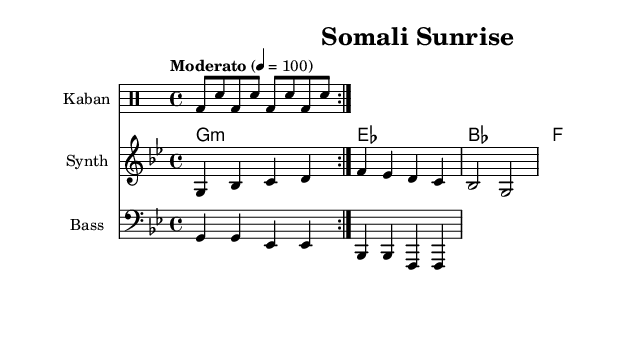What is the key signature of this music? The key signature indicates that the music is in G minor, which contains two flats (B flat and E flat). This is evidenced by the absence of any sharps and the presence of these flats in the key signature position.
Answer: G minor What is the time signature of this piece? The time signature is indicated by the number of beats in a measure. In this case, it shows 4 beats per measure, which is represented as 4/4 at the beginning of the score. This means each measure has four quarter-note beats.
Answer: 4/4 What is the tempo marking of the piece? The tempo marking is specified in the score as "Moderato" with a metronome marking of 100 beats per minute, indicating the speed at which the piece should be played.
Answer: Moderato 100 Which instrument plays the main drum part? The sheet music specifies the drum part under the "Kaban" instrument, suggesting that the primary rhythmic foundation of the piece is composed for Kaban drums.
Answer: Kaban What notes are played in the synth melody during the first measure? In the first measure, the synth melody plays notes G, B flat, C, and D. This can be determined by examining the notes positioned in the first measure of the synth staff.
Answer: G, B flat, C, D What chord is played in the second measure on the guitar? The second measure on the guitar is marked as "E flat major." This can be identified by looking at the chord symbols written above the measure on the chord staff.
Answer: E flat major How many measures are repeated for the drums? The drums are set to repeat the pattern for two measures, as indicated by the "repeat volta 2" instruction in the drum part. This detail shows that the rhythmic cycle outlined is intended to be played twice.
Answer: 2 